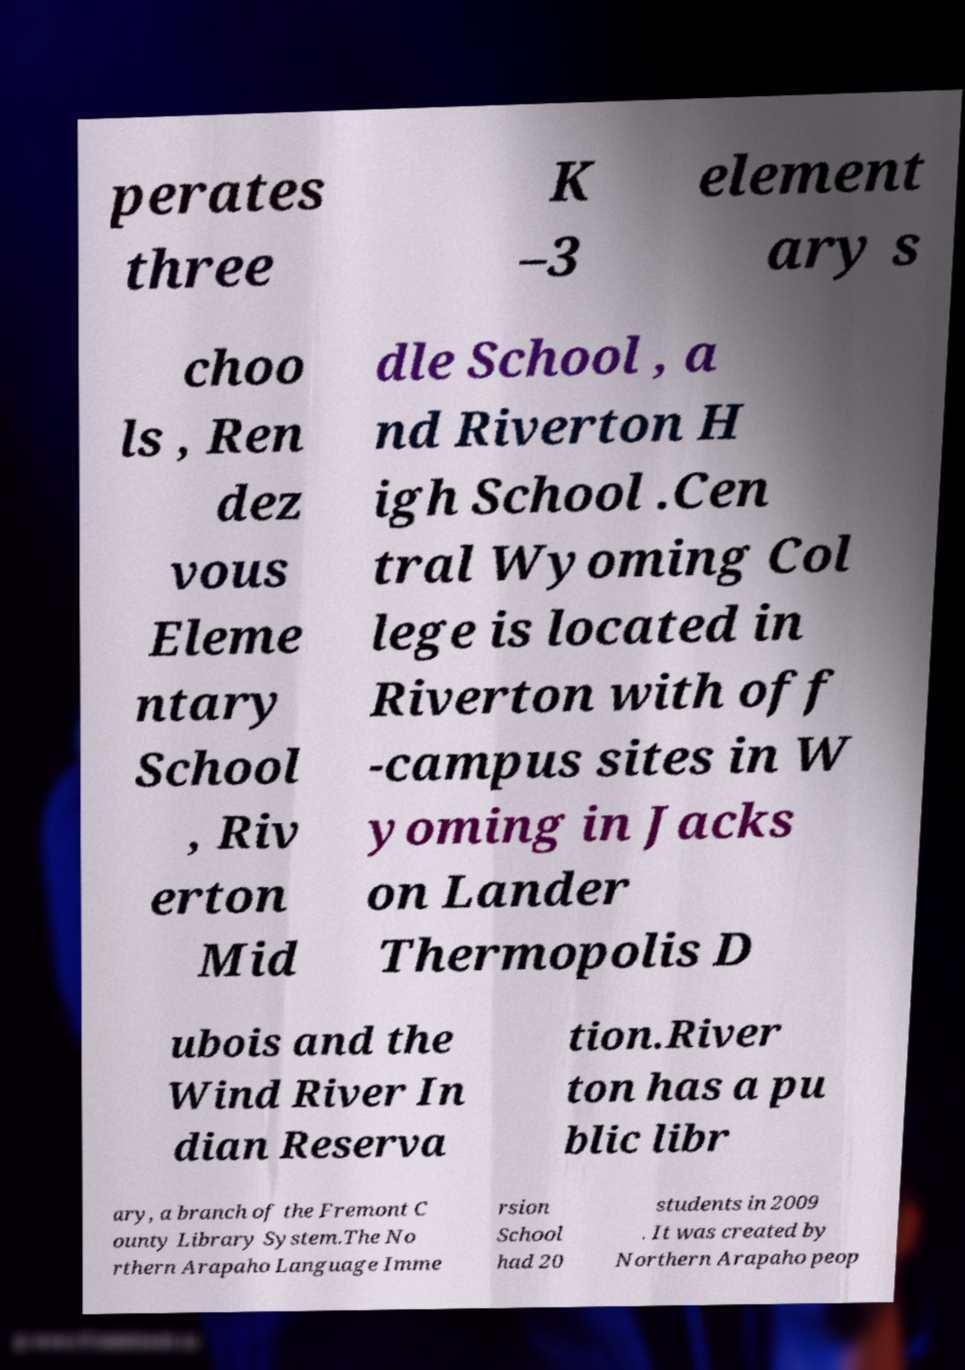There's text embedded in this image that I need extracted. Can you transcribe it verbatim? perates three K –3 element ary s choo ls , Ren dez vous Eleme ntary School , Riv erton Mid dle School , a nd Riverton H igh School .Cen tral Wyoming Col lege is located in Riverton with off -campus sites in W yoming in Jacks on Lander Thermopolis D ubois and the Wind River In dian Reserva tion.River ton has a pu blic libr ary, a branch of the Fremont C ounty Library System.The No rthern Arapaho Language Imme rsion School had 20 students in 2009 . It was created by Northern Arapaho peop 